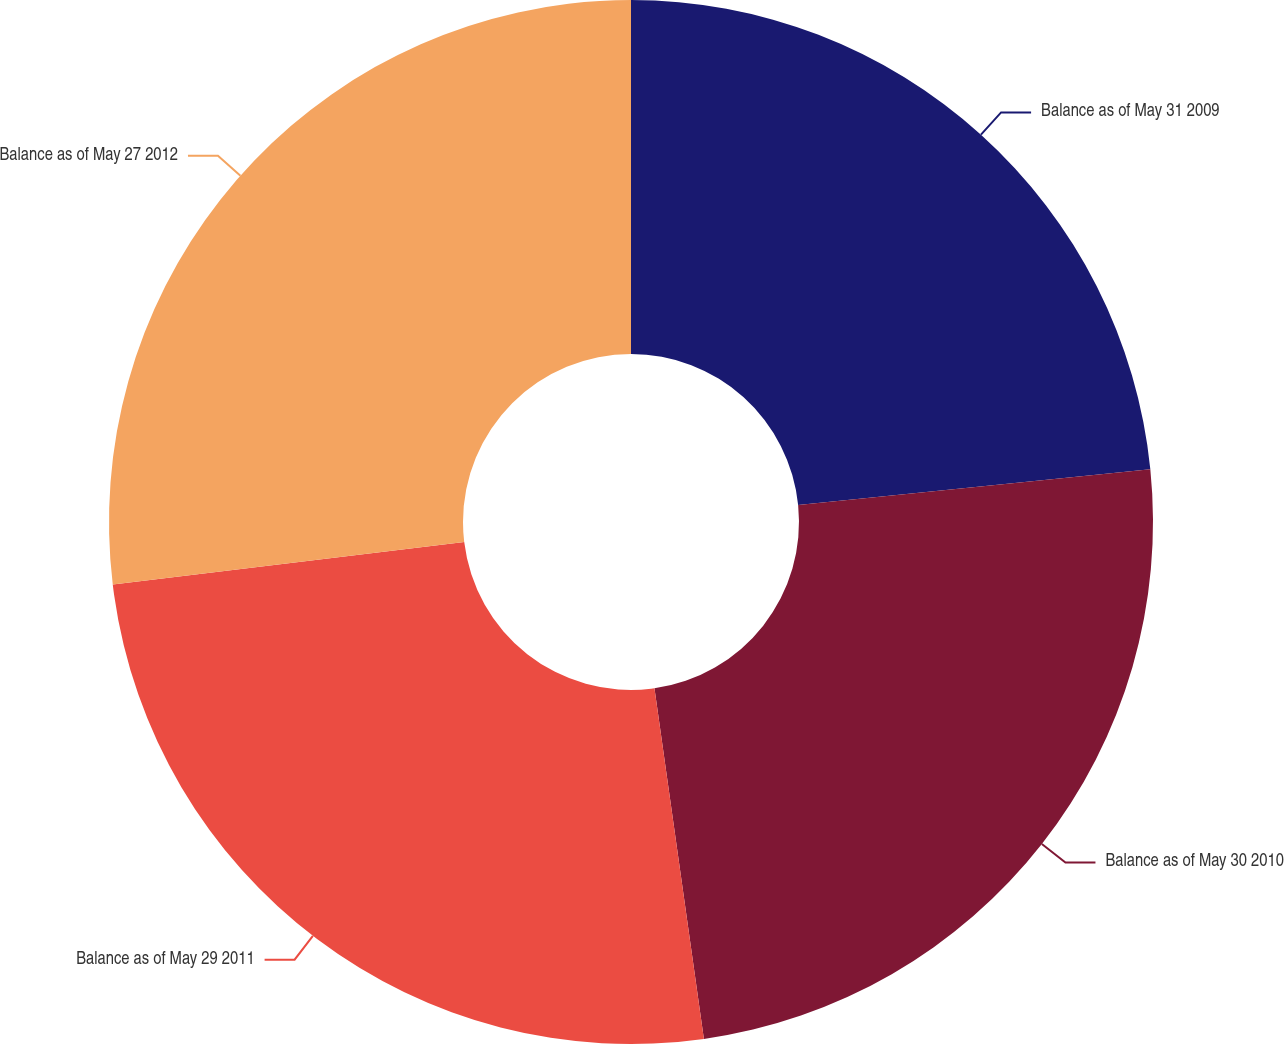Convert chart to OTSL. <chart><loc_0><loc_0><loc_500><loc_500><pie_chart><fcel>Balance as of May 31 2009<fcel>Balance as of May 30 2010<fcel>Balance as of May 29 2011<fcel>Balance as of May 27 2012<nl><fcel>23.39%<fcel>24.38%<fcel>25.32%<fcel>26.91%<nl></chart> 